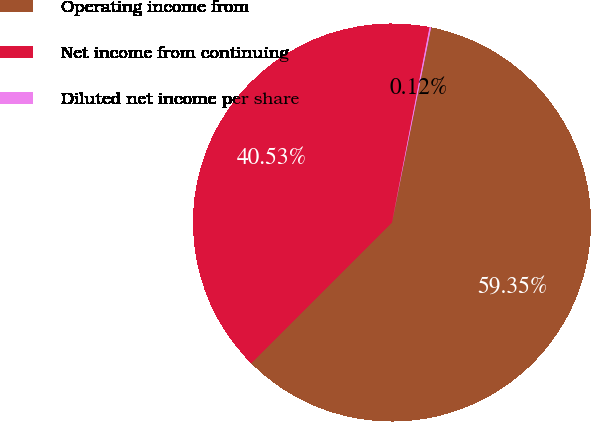Convert chart to OTSL. <chart><loc_0><loc_0><loc_500><loc_500><pie_chart><fcel>Operating income from<fcel>Net income from continuing<fcel>Diluted net income per share<nl><fcel>59.35%<fcel>40.53%<fcel>0.12%<nl></chart> 